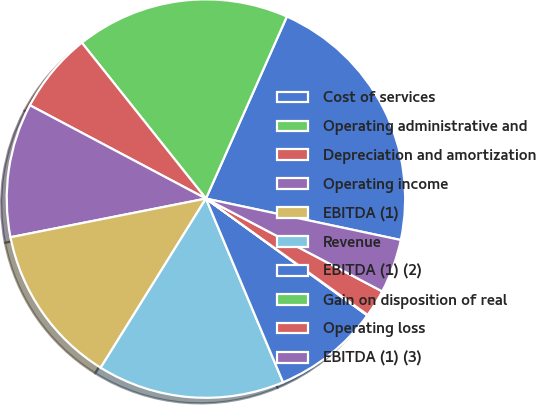Convert chart. <chart><loc_0><loc_0><loc_500><loc_500><pie_chart><fcel>Cost of services<fcel>Operating administrative and<fcel>Depreciation and amortization<fcel>Operating income<fcel>EBITDA (1)<fcel>Revenue<fcel>EBITDA (1) (2)<fcel>Gain on disposition of real<fcel>Operating loss<fcel>EBITDA (1) (3)<nl><fcel>21.68%<fcel>17.36%<fcel>6.54%<fcel>10.87%<fcel>13.03%<fcel>15.19%<fcel>8.7%<fcel>0.05%<fcel>2.21%<fcel>4.38%<nl></chart> 